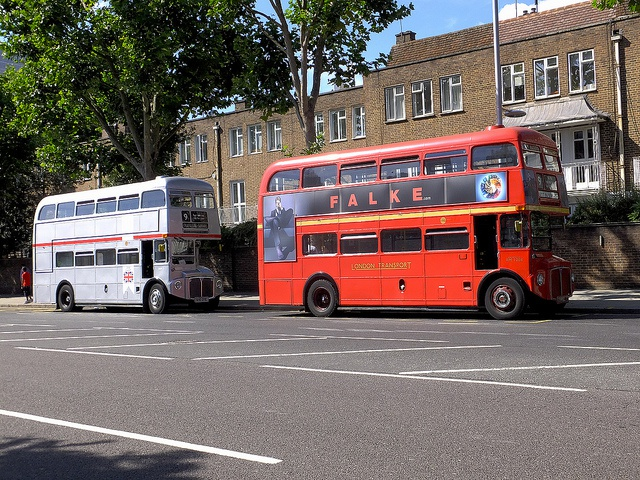Describe the objects in this image and their specific colors. I can see bus in darkgreen, black, red, and gray tones, bus in darkgreen, lavender, black, gray, and darkgray tones, people in darkgreen, gray, and darkgray tones, and people in darkgreen, maroon, black, gray, and brown tones in this image. 